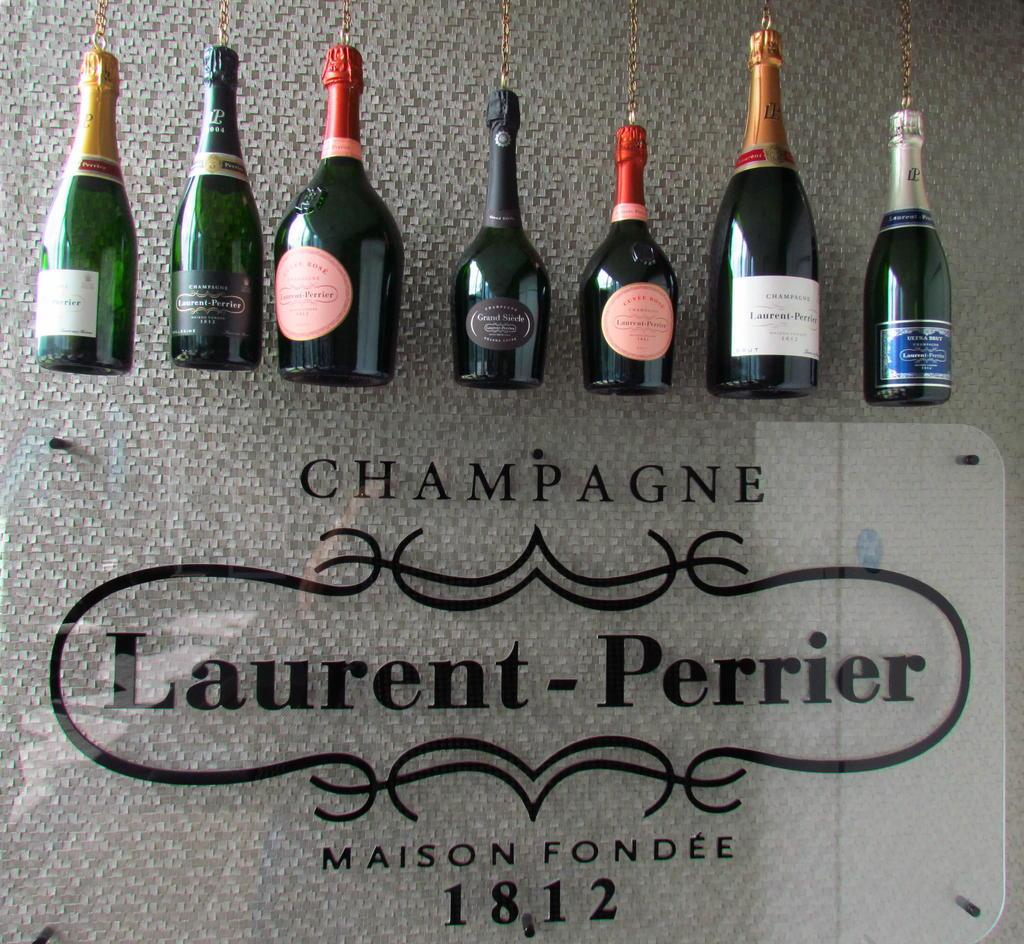<image>
Give a short and clear explanation of the subsequent image. The gold wrapped neck of a black bottle on the right side says Champagne Laurent - Perrier. 